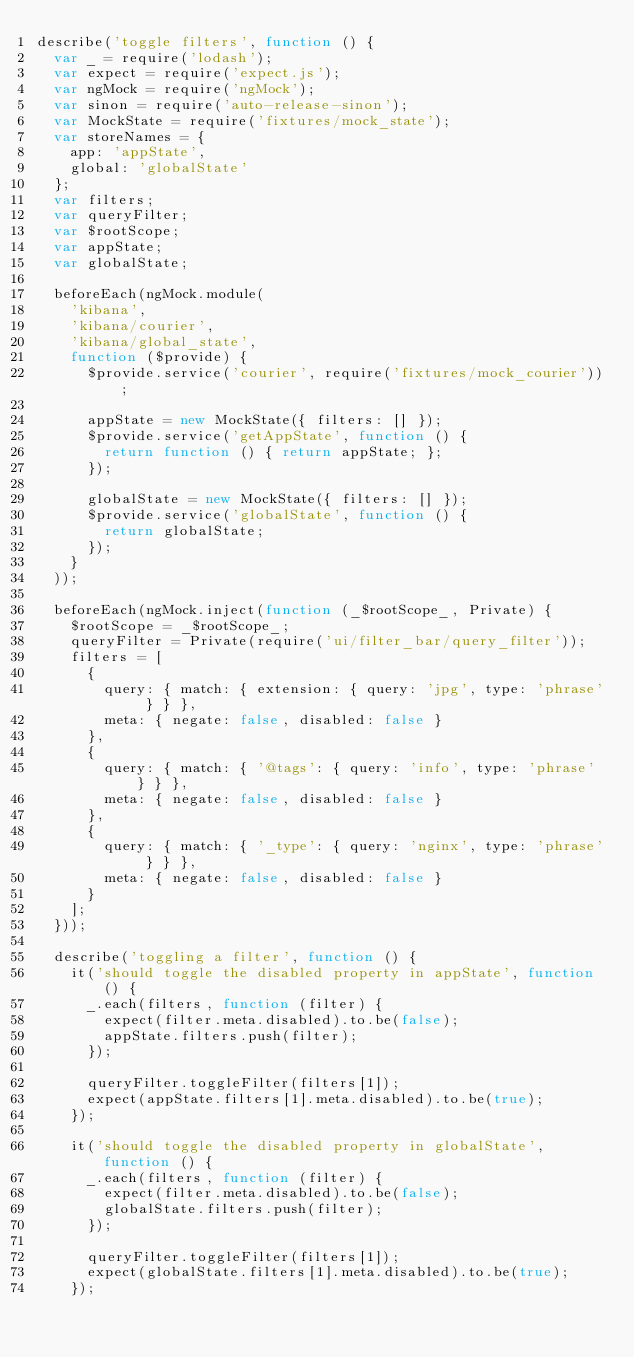Convert code to text. <code><loc_0><loc_0><loc_500><loc_500><_JavaScript_>describe('toggle filters', function () {
  var _ = require('lodash');
  var expect = require('expect.js');
  var ngMock = require('ngMock');
  var sinon = require('auto-release-sinon');
  var MockState = require('fixtures/mock_state');
  var storeNames = {
    app: 'appState',
    global: 'globalState'
  };
  var filters;
  var queryFilter;
  var $rootScope;
  var appState;
  var globalState;

  beforeEach(ngMock.module(
    'kibana',
    'kibana/courier',
    'kibana/global_state',
    function ($provide) {
      $provide.service('courier', require('fixtures/mock_courier'));

      appState = new MockState({ filters: [] });
      $provide.service('getAppState', function () {
        return function () { return appState; };
      });

      globalState = new MockState({ filters: [] });
      $provide.service('globalState', function () {
        return globalState;
      });
    }
  ));

  beforeEach(ngMock.inject(function (_$rootScope_, Private) {
    $rootScope = _$rootScope_;
    queryFilter = Private(require('ui/filter_bar/query_filter'));
    filters = [
      {
        query: { match: { extension: { query: 'jpg', type: 'phrase' } } },
        meta: { negate: false, disabled: false }
      },
      {
        query: { match: { '@tags': { query: 'info', type: 'phrase' } } },
        meta: { negate: false, disabled: false }
      },
      {
        query: { match: { '_type': { query: 'nginx', type: 'phrase' } } },
        meta: { negate: false, disabled: false }
      }
    ];
  }));

  describe('toggling a filter', function () {
    it('should toggle the disabled property in appState', function () {
      _.each(filters, function (filter) {
        expect(filter.meta.disabled).to.be(false);
        appState.filters.push(filter);
      });

      queryFilter.toggleFilter(filters[1]);
      expect(appState.filters[1].meta.disabled).to.be(true);
    });

    it('should toggle the disabled property in globalState', function () {
      _.each(filters, function (filter) {
        expect(filter.meta.disabled).to.be(false);
        globalState.filters.push(filter);
      });

      queryFilter.toggleFilter(filters[1]);
      expect(globalState.filters[1].meta.disabled).to.be(true);
    });
</code> 